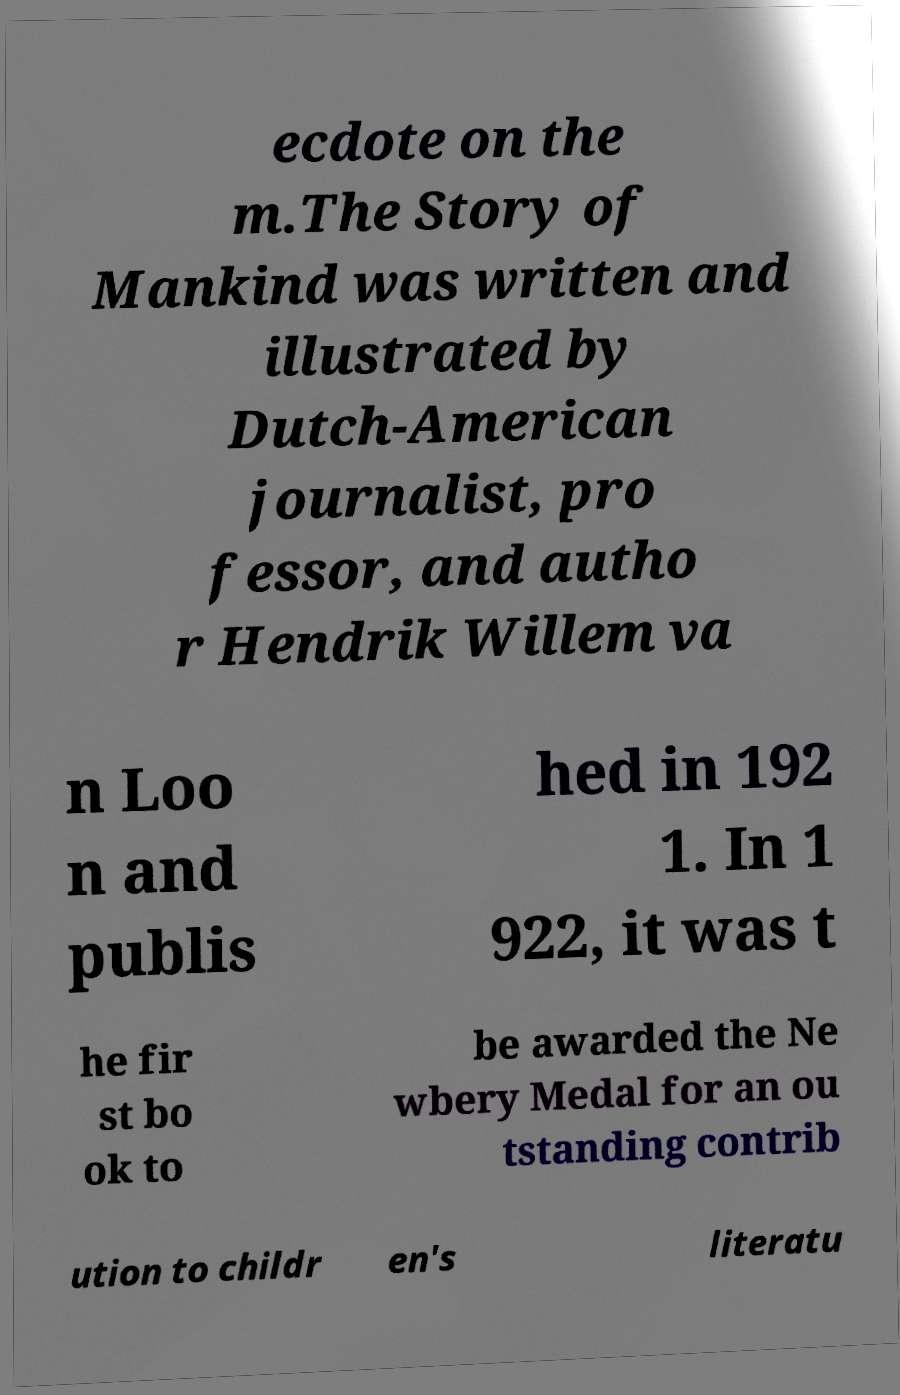Can you accurately transcribe the text from the provided image for me? ecdote on the m.The Story of Mankind was written and illustrated by Dutch-American journalist, pro fessor, and autho r Hendrik Willem va n Loo n and publis hed in 192 1. In 1 922, it was t he fir st bo ok to be awarded the Ne wbery Medal for an ou tstanding contrib ution to childr en's literatu 